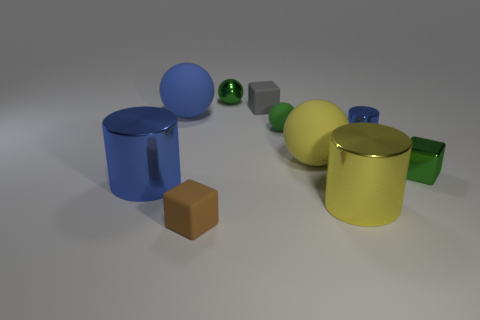What size is the green object that is the same shape as the gray matte thing?
Offer a terse response. Small. How big is the green block?
Provide a succinct answer. Small. Is the number of rubber objects in front of the green metal cube greater than the number of large green objects?
Your answer should be compact. Yes. There is a metal cylinder that is behind the green metal cube; is it the same color as the big metallic cylinder to the left of the tiny green rubber object?
Provide a short and direct response. Yes. There is a small thing left of the green metal object behind the blue metallic cylinder on the right side of the large blue cylinder; what is its material?
Keep it short and to the point. Rubber. Are there more purple balls than tiny shiny balls?
Provide a short and direct response. No. Is there any other thing that has the same color as the small shiny cylinder?
Your answer should be very brief. Yes. There is a blue thing that is the same material as the brown thing; what size is it?
Your answer should be very brief. Large. What material is the tiny gray thing?
Ensure brevity in your answer.  Rubber. How many rubber spheres have the same size as the gray matte cube?
Offer a terse response. 1. 